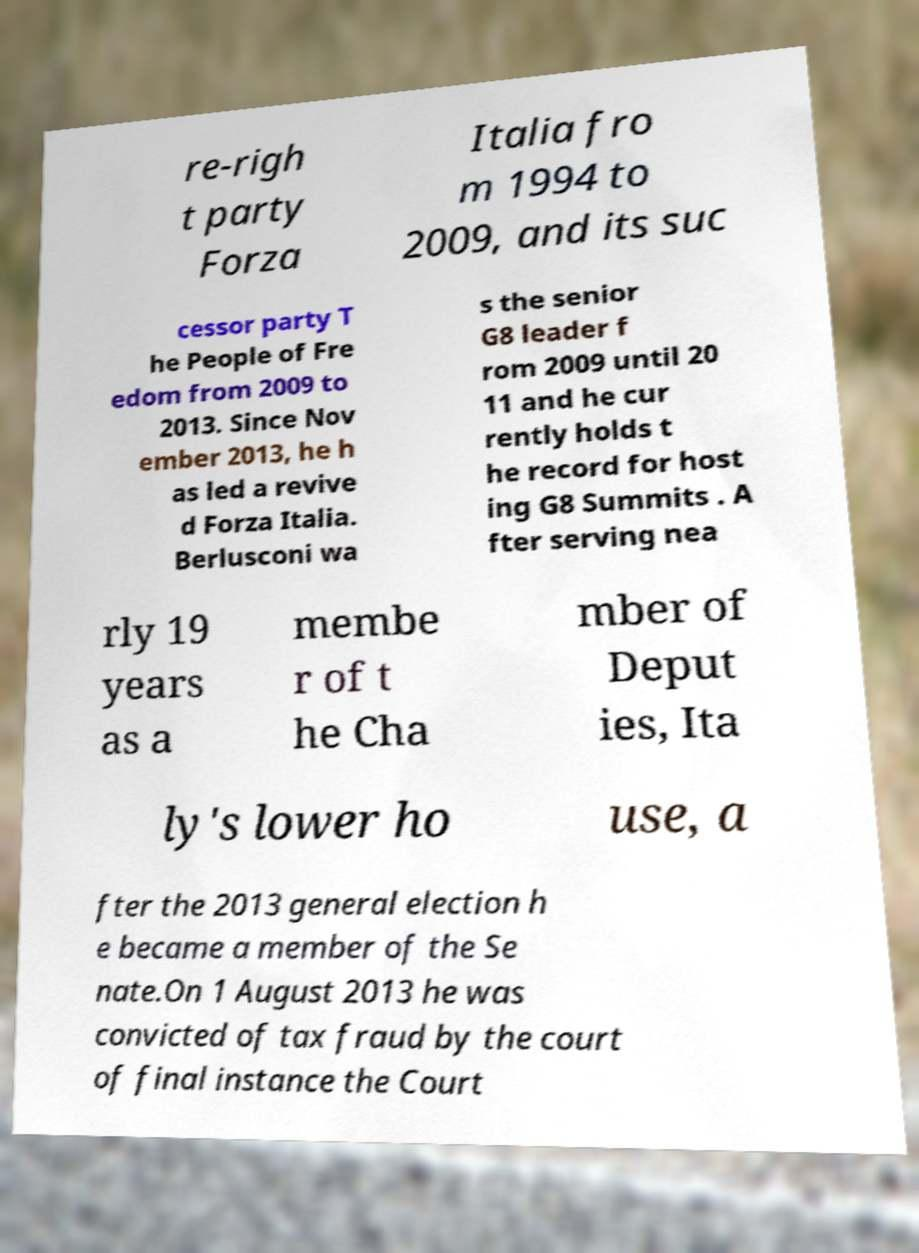Please read and relay the text visible in this image. What does it say? re-righ t party Forza Italia fro m 1994 to 2009, and its suc cessor party T he People of Fre edom from 2009 to 2013. Since Nov ember 2013, he h as led a revive d Forza Italia. Berlusconi wa s the senior G8 leader f rom 2009 until 20 11 and he cur rently holds t he record for host ing G8 Summits . A fter serving nea rly 19 years as a membe r of t he Cha mber of Deput ies, Ita ly's lower ho use, a fter the 2013 general election h e became a member of the Se nate.On 1 August 2013 he was convicted of tax fraud by the court of final instance the Court 